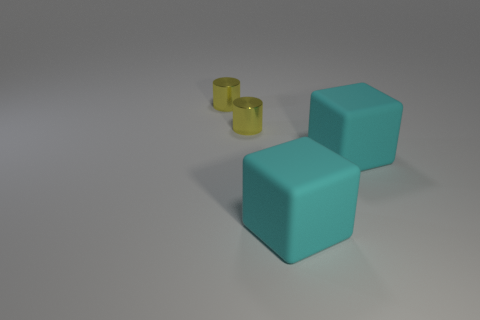Add 4 cyan blocks. How many objects exist? 8 Add 1 small objects. How many small objects exist? 3 Subtract 0 gray balls. How many objects are left? 4 Subtract all cyan rubber objects. Subtract all cylinders. How many objects are left? 0 Add 1 tiny metallic cylinders. How many tiny metallic cylinders are left? 3 